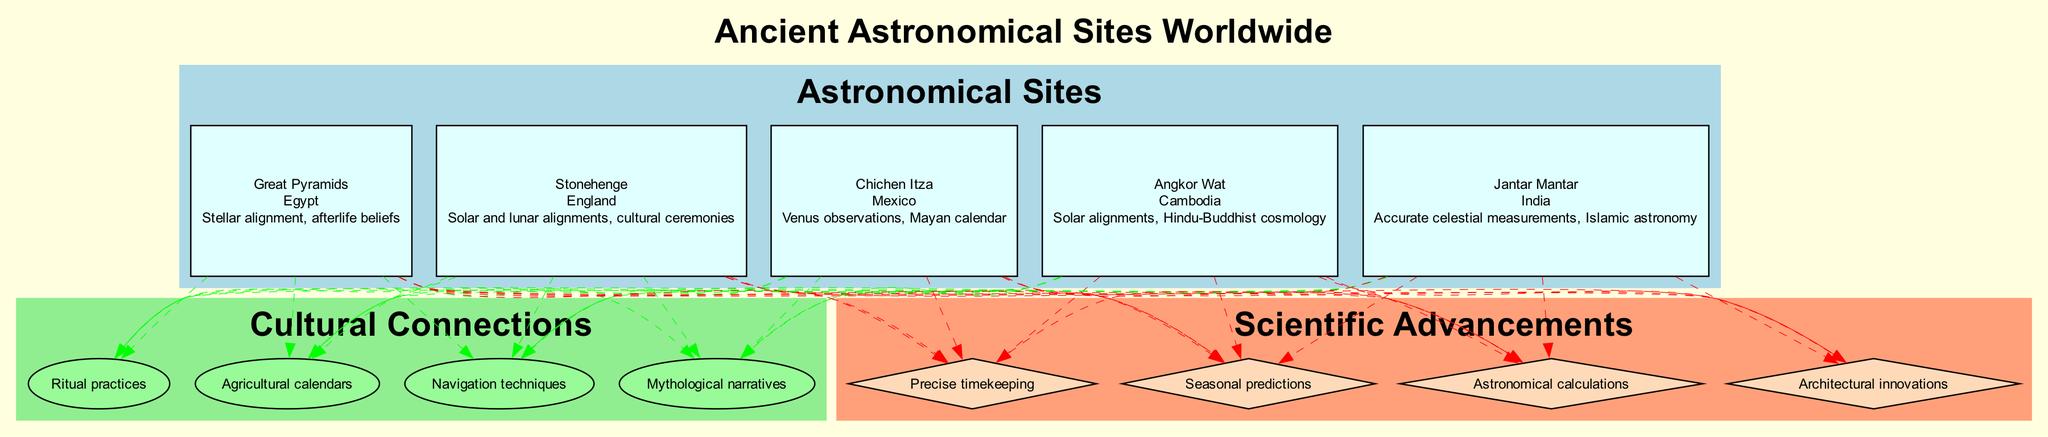What is the location of Stonehenge? The diagram displays the name 'Stonehenge' along with its respective location, which is indicated as 'England'.
Answer: England How many sites are listed in the diagram? By counting the number of nodes in the 'Astronomical Sites' subgraph, which shows five distinct entries (Stonehenge, Chichen Itza, Angkor Wat, Jantar Mantar, Great Pyramids), we determine that there are five sites.
Answer: 5 What is the main importance of Chichen Itza? The diagram highlights Chichen Itza's importance as 'Venus observations, Mayan calendar', which clearly explains its cultural significance.
Answer: Venus observations, Mayan calendar Which site is associated with Hindu-Buddhist cosmology? The connection for Angkor Wat in the diagram notes its cultural importance related to 'Hindu-Buddhist cosmology'.
Answer: Angkor Wat Which cultural connection is shared by all the sites shown? The 'Cultural Connections' subgraph displays a connection labeled 'Ritual practices', which is linked to each of the identified sites in the diagram, indicating that all of them are associated with this specific cultural connection.
Answer: Ritual practices What type of structure is used for 'Scientific Advancements'? The nodes under 'Scientific Advancements' are represented as diamonds, which is a specific shape used to depict this aspect in the diagram.
Answer: Diamond How many cultural connections are represented in the diagram? The diagram lists four distinct cultural connections indicated in the 'Cultural Connections' subgraph, leading us to conclude that there are four cultural connections.
Answer: 4 What site is connected to accurate celestial measurements? The node for Jantar Mantar specifies that it is associated with 'Accurate celestial measurements', which illustrates its scientific significance in the diagram.
Answer: Jantar Mantar Which site has a stellar alignment connection according to the diagram? The Great Pyramids node in the diagram mentions 'Stellar alignment', indicating its connection to this aspect.
Answer: Great Pyramids 